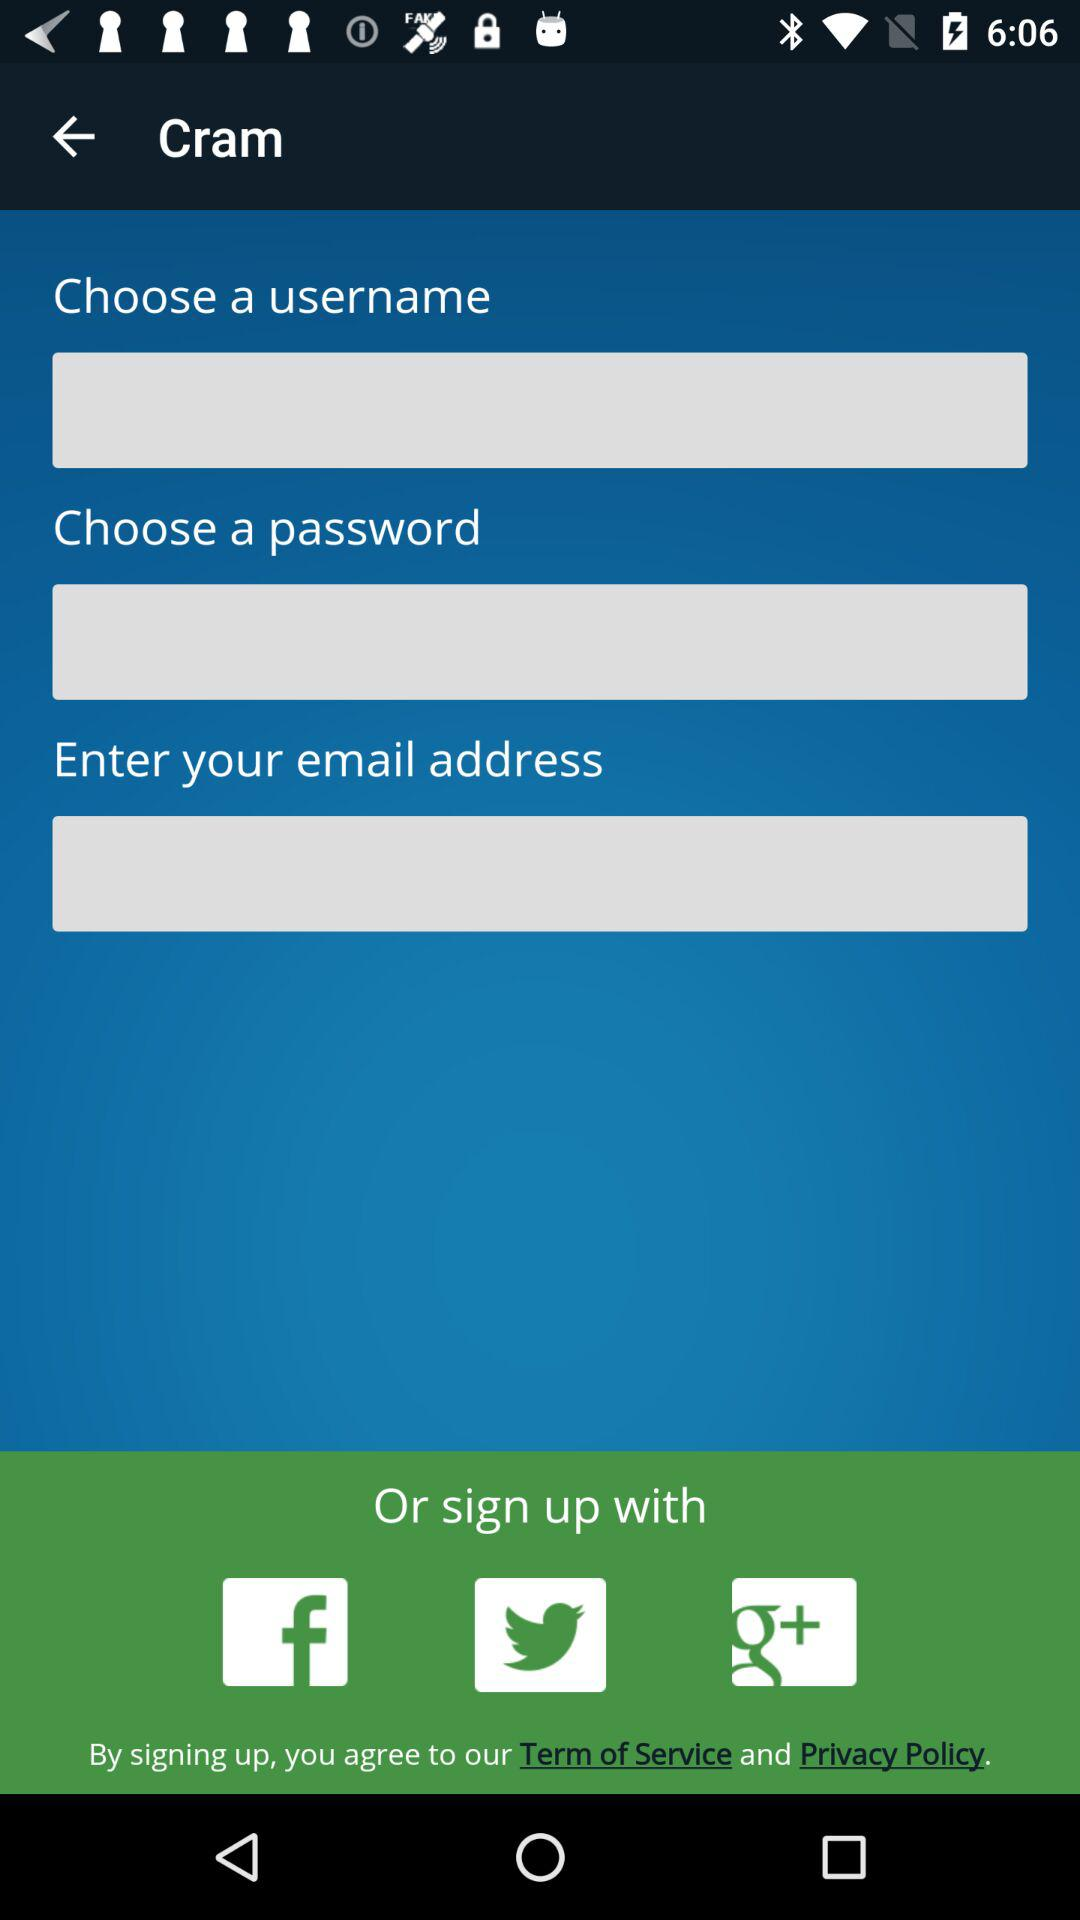How many text inputs are required to create an account?
Answer the question using a single word or phrase. 3 